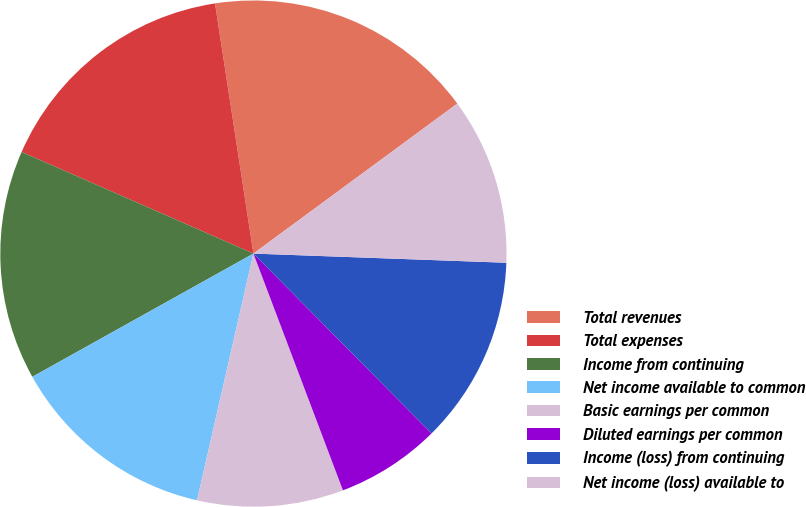Convert chart. <chart><loc_0><loc_0><loc_500><loc_500><pie_chart><fcel>Total revenues<fcel>Total expenses<fcel>Income from continuing<fcel>Net income available to common<fcel>Basic earnings per common<fcel>Diluted earnings per common<fcel>Income (loss) from continuing<fcel>Net income (loss) available to<nl><fcel>17.33%<fcel>16.0%<fcel>14.67%<fcel>13.33%<fcel>9.33%<fcel>6.67%<fcel>12.0%<fcel>10.67%<nl></chart> 